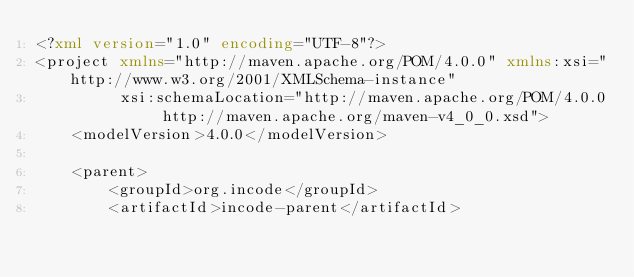<code> <loc_0><loc_0><loc_500><loc_500><_XML_><?xml version="1.0" encoding="UTF-8"?>
<project xmlns="http://maven.apache.org/POM/4.0.0" xmlns:xsi="http://www.w3.org/2001/XMLSchema-instance"
         xsi:schemaLocation="http://maven.apache.org/POM/4.0.0 http://maven.apache.org/maven-v4_0_0.xsd">
    <modelVersion>4.0.0</modelVersion>

    <parent>
        <groupId>org.incode</groupId>
        <artifactId>incode-parent</artifactId></code> 